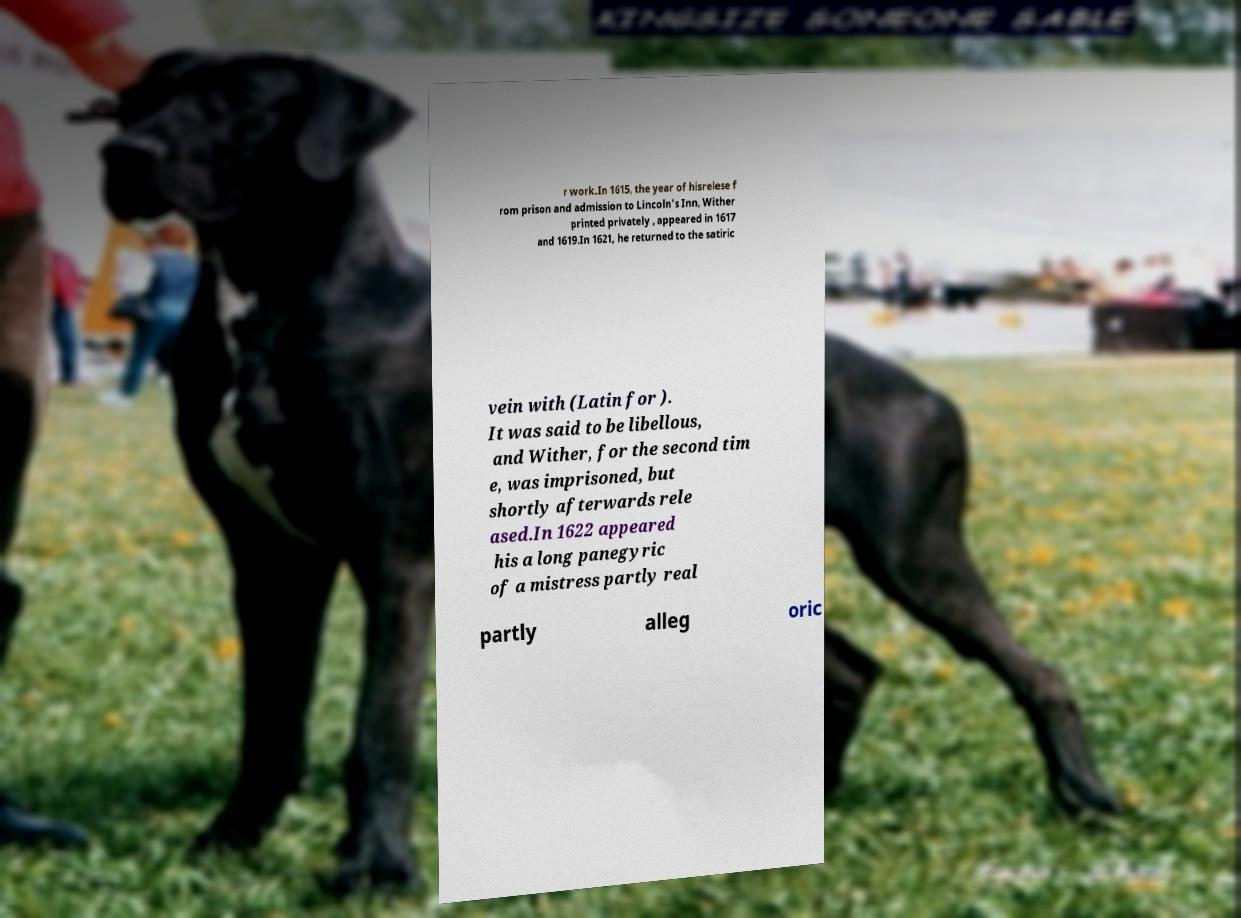Can you accurately transcribe the text from the provided image for me? r work.In 1615, the year of hisrelese f rom prison and admission to Lincoln's Inn, Wither printed privately , appeared in 1617 and 1619.In 1621, he returned to the satiric vein with (Latin for ). It was said to be libellous, and Wither, for the second tim e, was imprisoned, but shortly afterwards rele ased.In 1622 appeared his a long panegyric of a mistress partly real partly alleg oric 